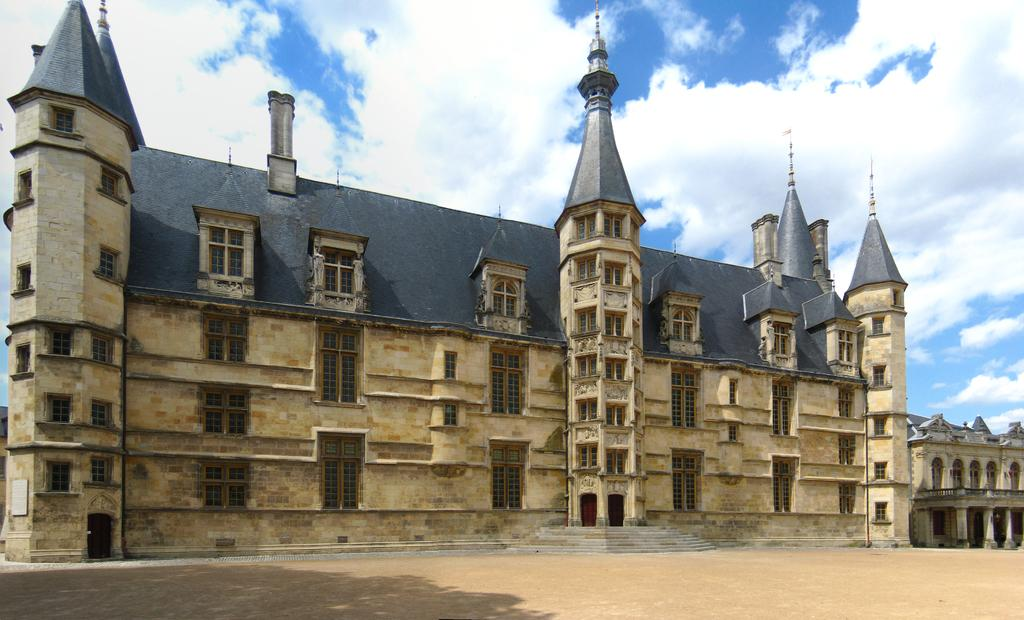What type of structures can be seen in the image? There are buildings in the image. What can be seen in the sky in the image? There are clouds in the sky in the image. What type of arch can be seen in the image? There is no arch present in the image. What kind of shoes are visible in the image? There are no shoes visible in the image. 